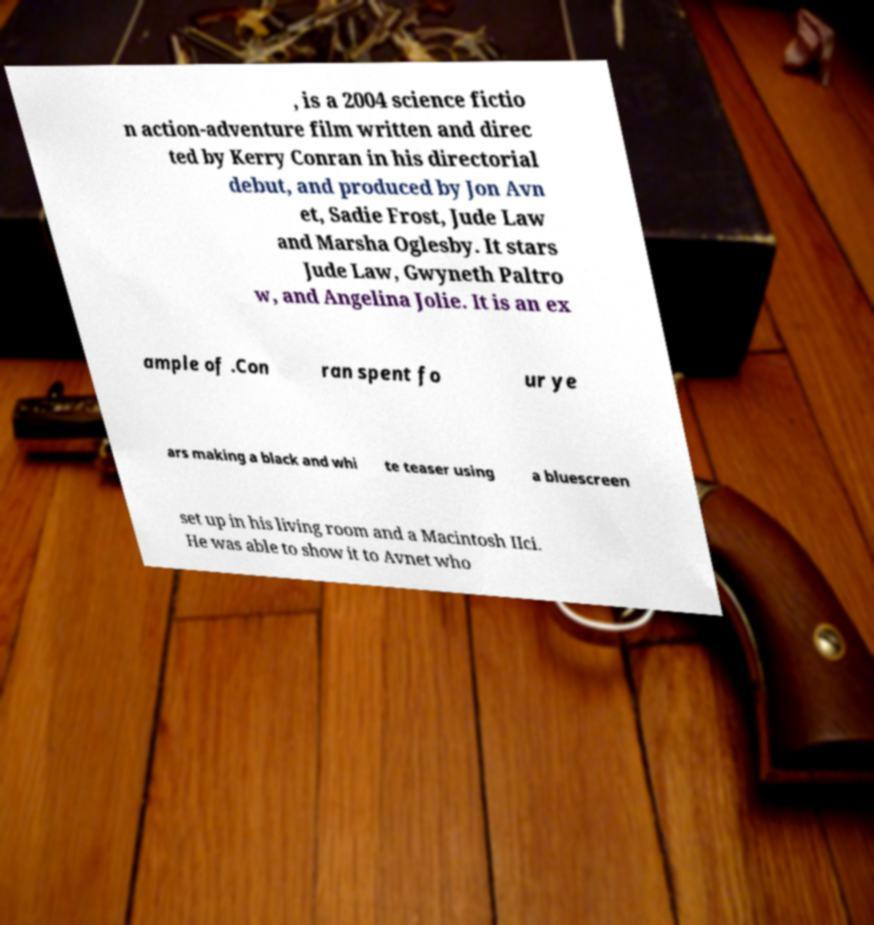Please read and relay the text visible in this image. What does it say? , is a 2004 science fictio n action-adventure film written and direc ted by Kerry Conran in his directorial debut, and produced by Jon Avn et, Sadie Frost, Jude Law and Marsha Oglesby. It stars Jude Law, Gwyneth Paltro w, and Angelina Jolie. It is an ex ample of .Con ran spent fo ur ye ars making a black and whi te teaser using a bluescreen set up in his living room and a Macintosh IIci. He was able to show it to Avnet who 